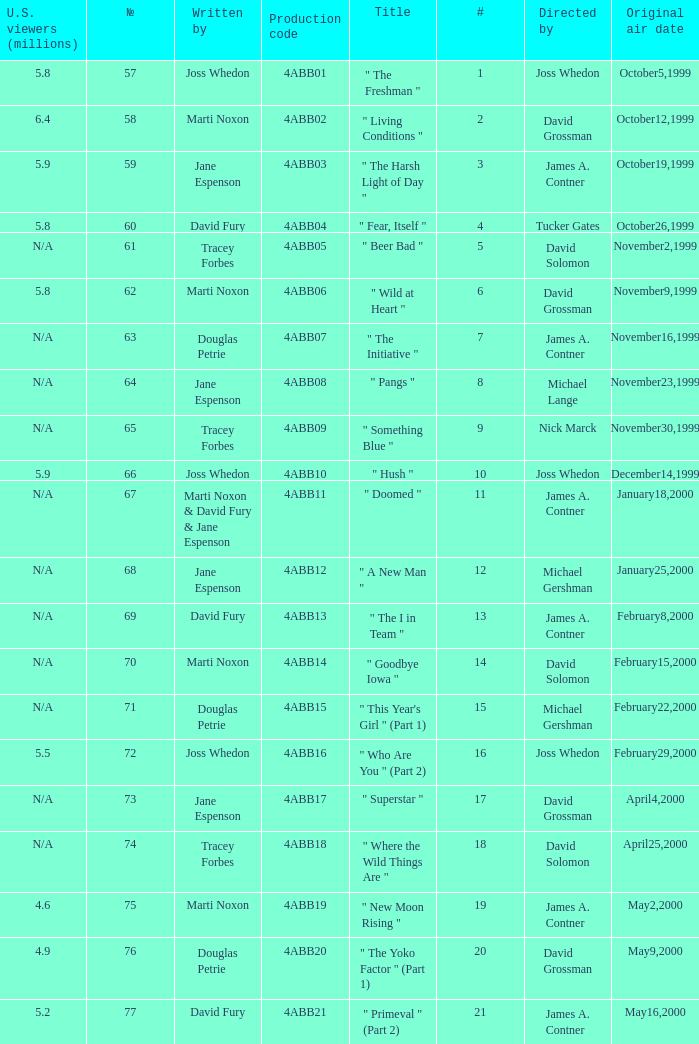What is the production code for the episode with 5.5 million u.s. viewers? 4ABB16. 